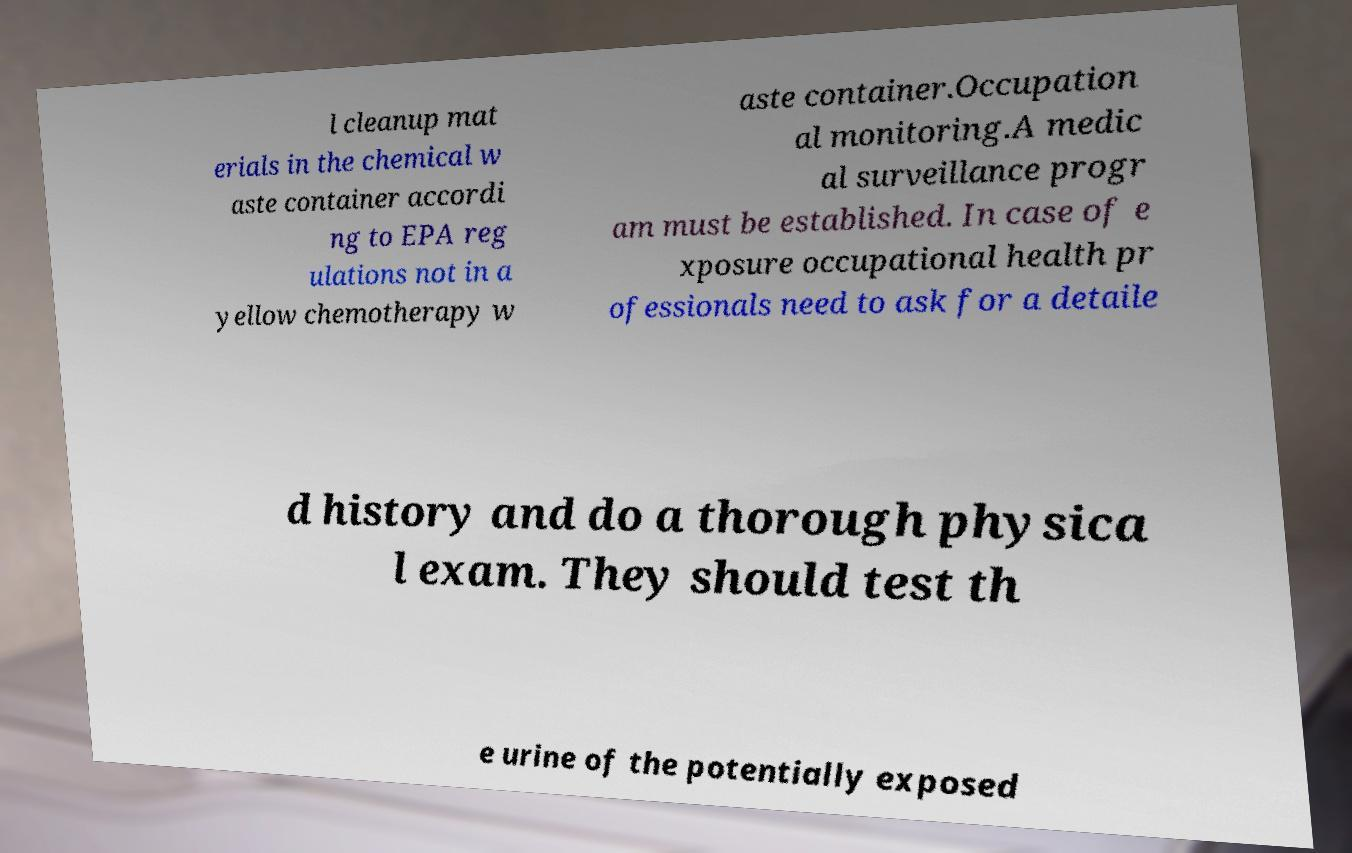I need the written content from this picture converted into text. Can you do that? l cleanup mat erials in the chemical w aste container accordi ng to EPA reg ulations not in a yellow chemotherapy w aste container.Occupation al monitoring.A medic al surveillance progr am must be established. In case of e xposure occupational health pr ofessionals need to ask for a detaile d history and do a thorough physica l exam. They should test th e urine of the potentially exposed 